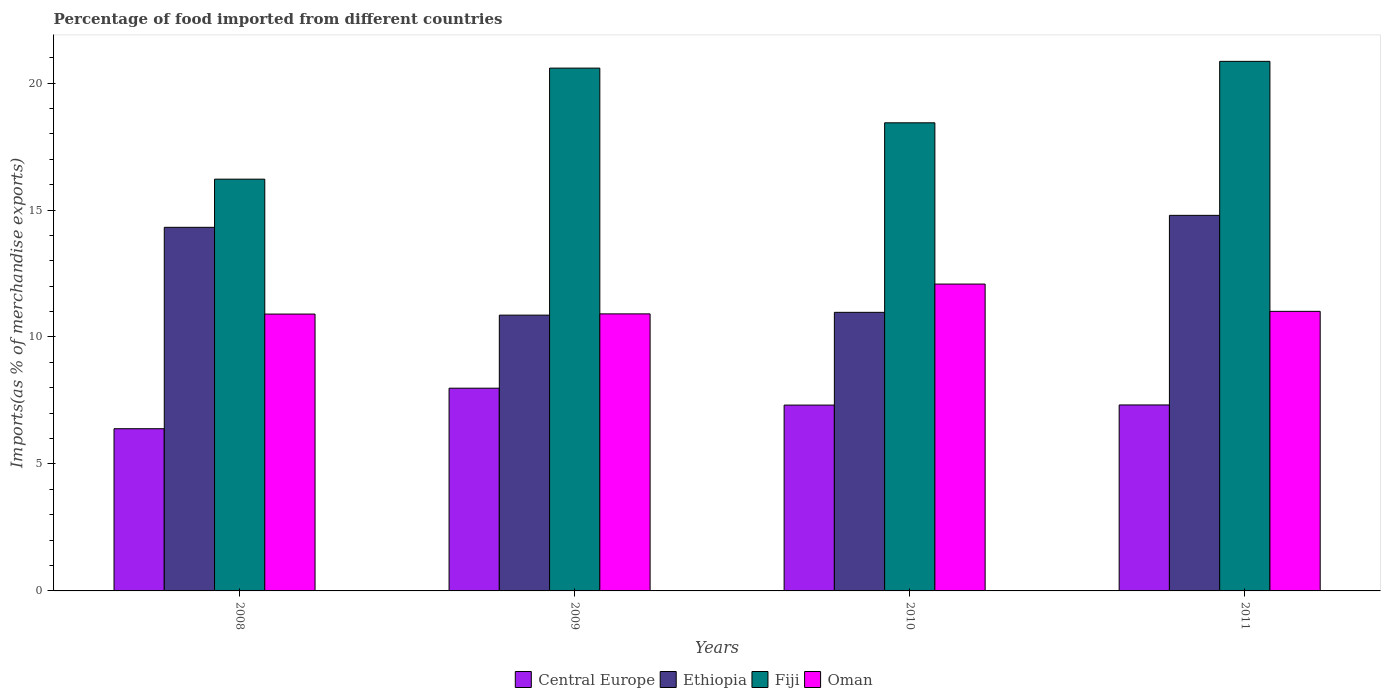How many different coloured bars are there?
Offer a very short reply. 4. How many groups of bars are there?
Offer a terse response. 4. Are the number of bars per tick equal to the number of legend labels?
Your answer should be very brief. Yes. How many bars are there on the 1st tick from the right?
Make the answer very short. 4. What is the label of the 3rd group of bars from the left?
Your answer should be very brief. 2010. What is the percentage of imports to different countries in Ethiopia in 2008?
Your answer should be compact. 14.32. Across all years, what is the maximum percentage of imports to different countries in Fiji?
Give a very brief answer. 20.85. Across all years, what is the minimum percentage of imports to different countries in Fiji?
Your answer should be compact. 16.22. In which year was the percentage of imports to different countries in Fiji maximum?
Provide a short and direct response. 2011. What is the total percentage of imports to different countries in Central Europe in the graph?
Give a very brief answer. 29.01. What is the difference between the percentage of imports to different countries in Central Europe in 2008 and that in 2010?
Give a very brief answer. -0.93. What is the difference between the percentage of imports to different countries in Central Europe in 2008 and the percentage of imports to different countries in Fiji in 2009?
Provide a succinct answer. -14.2. What is the average percentage of imports to different countries in Ethiopia per year?
Provide a succinct answer. 12.73. In the year 2010, what is the difference between the percentage of imports to different countries in Central Europe and percentage of imports to different countries in Fiji?
Offer a terse response. -11.12. What is the ratio of the percentage of imports to different countries in Ethiopia in 2008 to that in 2010?
Your answer should be compact. 1.31. Is the percentage of imports to different countries in Ethiopia in 2009 less than that in 2010?
Provide a succinct answer. Yes. Is the difference between the percentage of imports to different countries in Central Europe in 2008 and 2010 greater than the difference between the percentage of imports to different countries in Fiji in 2008 and 2010?
Your response must be concise. Yes. What is the difference between the highest and the second highest percentage of imports to different countries in Ethiopia?
Give a very brief answer. 0.47. What is the difference between the highest and the lowest percentage of imports to different countries in Ethiopia?
Offer a very short reply. 3.93. In how many years, is the percentage of imports to different countries in Ethiopia greater than the average percentage of imports to different countries in Ethiopia taken over all years?
Provide a succinct answer. 2. What does the 2nd bar from the left in 2008 represents?
Your answer should be compact. Ethiopia. What does the 4th bar from the right in 2010 represents?
Your answer should be very brief. Central Europe. Is it the case that in every year, the sum of the percentage of imports to different countries in Central Europe and percentage of imports to different countries in Oman is greater than the percentage of imports to different countries in Ethiopia?
Your answer should be compact. Yes. Where does the legend appear in the graph?
Your answer should be compact. Bottom center. How many legend labels are there?
Offer a terse response. 4. How are the legend labels stacked?
Make the answer very short. Horizontal. What is the title of the graph?
Keep it short and to the point. Percentage of food imported from different countries. What is the label or title of the Y-axis?
Offer a terse response. Imports(as % of merchandise exports). What is the Imports(as % of merchandise exports) in Central Europe in 2008?
Keep it short and to the point. 6.39. What is the Imports(as % of merchandise exports) in Ethiopia in 2008?
Your response must be concise. 14.32. What is the Imports(as % of merchandise exports) in Fiji in 2008?
Your answer should be very brief. 16.22. What is the Imports(as % of merchandise exports) in Oman in 2008?
Offer a terse response. 10.9. What is the Imports(as % of merchandise exports) in Central Europe in 2009?
Your answer should be very brief. 7.98. What is the Imports(as % of merchandise exports) of Ethiopia in 2009?
Keep it short and to the point. 10.86. What is the Imports(as % of merchandise exports) in Fiji in 2009?
Give a very brief answer. 20.59. What is the Imports(as % of merchandise exports) in Oman in 2009?
Keep it short and to the point. 10.91. What is the Imports(as % of merchandise exports) in Central Europe in 2010?
Provide a short and direct response. 7.32. What is the Imports(as % of merchandise exports) of Ethiopia in 2010?
Provide a succinct answer. 10.97. What is the Imports(as % of merchandise exports) in Fiji in 2010?
Provide a succinct answer. 18.43. What is the Imports(as % of merchandise exports) of Oman in 2010?
Provide a succinct answer. 12.08. What is the Imports(as % of merchandise exports) of Central Europe in 2011?
Your answer should be compact. 7.32. What is the Imports(as % of merchandise exports) of Ethiopia in 2011?
Your answer should be very brief. 14.79. What is the Imports(as % of merchandise exports) of Fiji in 2011?
Provide a succinct answer. 20.85. What is the Imports(as % of merchandise exports) of Oman in 2011?
Give a very brief answer. 11.01. Across all years, what is the maximum Imports(as % of merchandise exports) in Central Europe?
Give a very brief answer. 7.98. Across all years, what is the maximum Imports(as % of merchandise exports) in Ethiopia?
Give a very brief answer. 14.79. Across all years, what is the maximum Imports(as % of merchandise exports) of Fiji?
Provide a short and direct response. 20.85. Across all years, what is the maximum Imports(as % of merchandise exports) in Oman?
Make the answer very short. 12.08. Across all years, what is the minimum Imports(as % of merchandise exports) in Central Europe?
Your answer should be very brief. 6.39. Across all years, what is the minimum Imports(as % of merchandise exports) in Ethiopia?
Give a very brief answer. 10.86. Across all years, what is the minimum Imports(as % of merchandise exports) of Fiji?
Provide a short and direct response. 16.22. Across all years, what is the minimum Imports(as % of merchandise exports) of Oman?
Provide a short and direct response. 10.9. What is the total Imports(as % of merchandise exports) of Central Europe in the graph?
Your answer should be compact. 29.01. What is the total Imports(as % of merchandise exports) in Ethiopia in the graph?
Provide a short and direct response. 50.94. What is the total Imports(as % of merchandise exports) of Fiji in the graph?
Your answer should be very brief. 76.09. What is the total Imports(as % of merchandise exports) of Oman in the graph?
Ensure brevity in your answer.  44.91. What is the difference between the Imports(as % of merchandise exports) of Central Europe in 2008 and that in 2009?
Your answer should be compact. -1.6. What is the difference between the Imports(as % of merchandise exports) in Ethiopia in 2008 and that in 2009?
Your answer should be compact. 3.46. What is the difference between the Imports(as % of merchandise exports) in Fiji in 2008 and that in 2009?
Your answer should be very brief. -4.37. What is the difference between the Imports(as % of merchandise exports) in Oman in 2008 and that in 2009?
Offer a very short reply. -0.01. What is the difference between the Imports(as % of merchandise exports) of Central Europe in 2008 and that in 2010?
Offer a terse response. -0.93. What is the difference between the Imports(as % of merchandise exports) in Ethiopia in 2008 and that in 2010?
Ensure brevity in your answer.  3.35. What is the difference between the Imports(as % of merchandise exports) of Fiji in 2008 and that in 2010?
Give a very brief answer. -2.22. What is the difference between the Imports(as % of merchandise exports) of Oman in 2008 and that in 2010?
Your answer should be very brief. -1.18. What is the difference between the Imports(as % of merchandise exports) of Central Europe in 2008 and that in 2011?
Ensure brevity in your answer.  -0.94. What is the difference between the Imports(as % of merchandise exports) in Ethiopia in 2008 and that in 2011?
Keep it short and to the point. -0.47. What is the difference between the Imports(as % of merchandise exports) of Fiji in 2008 and that in 2011?
Provide a short and direct response. -4.64. What is the difference between the Imports(as % of merchandise exports) of Oman in 2008 and that in 2011?
Your answer should be compact. -0.11. What is the difference between the Imports(as % of merchandise exports) of Central Europe in 2009 and that in 2010?
Your answer should be compact. 0.67. What is the difference between the Imports(as % of merchandise exports) in Ethiopia in 2009 and that in 2010?
Offer a terse response. -0.11. What is the difference between the Imports(as % of merchandise exports) in Fiji in 2009 and that in 2010?
Ensure brevity in your answer.  2.15. What is the difference between the Imports(as % of merchandise exports) of Oman in 2009 and that in 2010?
Your answer should be very brief. -1.17. What is the difference between the Imports(as % of merchandise exports) of Central Europe in 2009 and that in 2011?
Offer a very short reply. 0.66. What is the difference between the Imports(as % of merchandise exports) of Ethiopia in 2009 and that in 2011?
Your answer should be compact. -3.93. What is the difference between the Imports(as % of merchandise exports) in Fiji in 2009 and that in 2011?
Provide a succinct answer. -0.27. What is the difference between the Imports(as % of merchandise exports) in Oman in 2009 and that in 2011?
Your answer should be very brief. -0.1. What is the difference between the Imports(as % of merchandise exports) in Central Europe in 2010 and that in 2011?
Your response must be concise. -0.01. What is the difference between the Imports(as % of merchandise exports) in Ethiopia in 2010 and that in 2011?
Keep it short and to the point. -3.82. What is the difference between the Imports(as % of merchandise exports) of Fiji in 2010 and that in 2011?
Your response must be concise. -2.42. What is the difference between the Imports(as % of merchandise exports) of Oman in 2010 and that in 2011?
Provide a succinct answer. 1.07. What is the difference between the Imports(as % of merchandise exports) of Central Europe in 2008 and the Imports(as % of merchandise exports) of Ethiopia in 2009?
Make the answer very short. -4.47. What is the difference between the Imports(as % of merchandise exports) in Central Europe in 2008 and the Imports(as % of merchandise exports) in Fiji in 2009?
Your answer should be very brief. -14.2. What is the difference between the Imports(as % of merchandise exports) of Central Europe in 2008 and the Imports(as % of merchandise exports) of Oman in 2009?
Offer a terse response. -4.52. What is the difference between the Imports(as % of merchandise exports) in Ethiopia in 2008 and the Imports(as % of merchandise exports) in Fiji in 2009?
Offer a terse response. -6.27. What is the difference between the Imports(as % of merchandise exports) of Ethiopia in 2008 and the Imports(as % of merchandise exports) of Oman in 2009?
Your response must be concise. 3.41. What is the difference between the Imports(as % of merchandise exports) of Fiji in 2008 and the Imports(as % of merchandise exports) of Oman in 2009?
Give a very brief answer. 5.31. What is the difference between the Imports(as % of merchandise exports) in Central Europe in 2008 and the Imports(as % of merchandise exports) in Ethiopia in 2010?
Provide a succinct answer. -4.58. What is the difference between the Imports(as % of merchandise exports) of Central Europe in 2008 and the Imports(as % of merchandise exports) of Fiji in 2010?
Your answer should be very brief. -12.05. What is the difference between the Imports(as % of merchandise exports) in Central Europe in 2008 and the Imports(as % of merchandise exports) in Oman in 2010?
Ensure brevity in your answer.  -5.7. What is the difference between the Imports(as % of merchandise exports) of Ethiopia in 2008 and the Imports(as % of merchandise exports) of Fiji in 2010?
Give a very brief answer. -4.12. What is the difference between the Imports(as % of merchandise exports) of Ethiopia in 2008 and the Imports(as % of merchandise exports) of Oman in 2010?
Ensure brevity in your answer.  2.23. What is the difference between the Imports(as % of merchandise exports) in Fiji in 2008 and the Imports(as % of merchandise exports) in Oman in 2010?
Keep it short and to the point. 4.13. What is the difference between the Imports(as % of merchandise exports) of Central Europe in 2008 and the Imports(as % of merchandise exports) of Ethiopia in 2011?
Your answer should be compact. -8.4. What is the difference between the Imports(as % of merchandise exports) in Central Europe in 2008 and the Imports(as % of merchandise exports) in Fiji in 2011?
Provide a short and direct response. -14.47. What is the difference between the Imports(as % of merchandise exports) of Central Europe in 2008 and the Imports(as % of merchandise exports) of Oman in 2011?
Provide a succinct answer. -4.62. What is the difference between the Imports(as % of merchandise exports) of Ethiopia in 2008 and the Imports(as % of merchandise exports) of Fiji in 2011?
Keep it short and to the point. -6.54. What is the difference between the Imports(as % of merchandise exports) of Ethiopia in 2008 and the Imports(as % of merchandise exports) of Oman in 2011?
Your response must be concise. 3.31. What is the difference between the Imports(as % of merchandise exports) of Fiji in 2008 and the Imports(as % of merchandise exports) of Oman in 2011?
Make the answer very short. 5.21. What is the difference between the Imports(as % of merchandise exports) in Central Europe in 2009 and the Imports(as % of merchandise exports) in Ethiopia in 2010?
Offer a very short reply. -2.99. What is the difference between the Imports(as % of merchandise exports) in Central Europe in 2009 and the Imports(as % of merchandise exports) in Fiji in 2010?
Offer a terse response. -10.45. What is the difference between the Imports(as % of merchandise exports) of Central Europe in 2009 and the Imports(as % of merchandise exports) of Oman in 2010?
Give a very brief answer. -4.1. What is the difference between the Imports(as % of merchandise exports) in Ethiopia in 2009 and the Imports(as % of merchandise exports) in Fiji in 2010?
Offer a very short reply. -7.57. What is the difference between the Imports(as % of merchandise exports) in Ethiopia in 2009 and the Imports(as % of merchandise exports) in Oman in 2010?
Your response must be concise. -1.22. What is the difference between the Imports(as % of merchandise exports) in Fiji in 2009 and the Imports(as % of merchandise exports) in Oman in 2010?
Provide a short and direct response. 8.5. What is the difference between the Imports(as % of merchandise exports) of Central Europe in 2009 and the Imports(as % of merchandise exports) of Ethiopia in 2011?
Make the answer very short. -6.81. What is the difference between the Imports(as % of merchandise exports) in Central Europe in 2009 and the Imports(as % of merchandise exports) in Fiji in 2011?
Your answer should be compact. -12.87. What is the difference between the Imports(as % of merchandise exports) in Central Europe in 2009 and the Imports(as % of merchandise exports) in Oman in 2011?
Offer a very short reply. -3.03. What is the difference between the Imports(as % of merchandise exports) of Ethiopia in 2009 and the Imports(as % of merchandise exports) of Fiji in 2011?
Provide a short and direct response. -9.99. What is the difference between the Imports(as % of merchandise exports) in Ethiopia in 2009 and the Imports(as % of merchandise exports) in Oman in 2011?
Offer a very short reply. -0.15. What is the difference between the Imports(as % of merchandise exports) in Fiji in 2009 and the Imports(as % of merchandise exports) in Oman in 2011?
Offer a terse response. 9.58. What is the difference between the Imports(as % of merchandise exports) in Central Europe in 2010 and the Imports(as % of merchandise exports) in Ethiopia in 2011?
Offer a terse response. -7.47. What is the difference between the Imports(as % of merchandise exports) of Central Europe in 2010 and the Imports(as % of merchandise exports) of Fiji in 2011?
Offer a very short reply. -13.54. What is the difference between the Imports(as % of merchandise exports) in Central Europe in 2010 and the Imports(as % of merchandise exports) in Oman in 2011?
Offer a terse response. -3.69. What is the difference between the Imports(as % of merchandise exports) of Ethiopia in 2010 and the Imports(as % of merchandise exports) of Fiji in 2011?
Your answer should be compact. -9.88. What is the difference between the Imports(as % of merchandise exports) of Ethiopia in 2010 and the Imports(as % of merchandise exports) of Oman in 2011?
Your answer should be very brief. -0.04. What is the difference between the Imports(as % of merchandise exports) in Fiji in 2010 and the Imports(as % of merchandise exports) in Oman in 2011?
Offer a terse response. 7.43. What is the average Imports(as % of merchandise exports) of Central Europe per year?
Ensure brevity in your answer.  7.25. What is the average Imports(as % of merchandise exports) of Ethiopia per year?
Offer a terse response. 12.73. What is the average Imports(as % of merchandise exports) of Fiji per year?
Ensure brevity in your answer.  19.02. What is the average Imports(as % of merchandise exports) in Oman per year?
Your answer should be compact. 11.23. In the year 2008, what is the difference between the Imports(as % of merchandise exports) in Central Europe and Imports(as % of merchandise exports) in Ethiopia?
Offer a very short reply. -7.93. In the year 2008, what is the difference between the Imports(as % of merchandise exports) of Central Europe and Imports(as % of merchandise exports) of Fiji?
Offer a terse response. -9.83. In the year 2008, what is the difference between the Imports(as % of merchandise exports) of Central Europe and Imports(as % of merchandise exports) of Oman?
Give a very brief answer. -4.51. In the year 2008, what is the difference between the Imports(as % of merchandise exports) in Ethiopia and Imports(as % of merchandise exports) in Fiji?
Offer a very short reply. -1.9. In the year 2008, what is the difference between the Imports(as % of merchandise exports) of Ethiopia and Imports(as % of merchandise exports) of Oman?
Make the answer very short. 3.42. In the year 2008, what is the difference between the Imports(as % of merchandise exports) of Fiji and Imports(as % of merchandise exports) of Oman?
Give a very brief answer. 5.31. In the year 2009, what is the difference between the Imports(as % of merchandise exports) in Central Europe and Imports(as % of merchandise exports) in Ethiopia?
Ensure brevity in your answer.  -2.88. In the year 2009, what is the difference between the Imports(as % of merchandise exports) in Central Europe and Imports(as % of merchandise exports) in Fiji?
Your answer should be very brief. -12.6. In the year 2009, what is the difference between the Imports(as % of merchandise exports) of Central Europe and Imports(as % of merchandise exports) of Oman?
Offer a terse response. -2.93. In the year 2009, what is the difference between the Imports(as % of merchandise exports) in Ethiopia and Imports(as % of merchandise exports) in Fiji?
Your answer should be compact. -9.73. In the year 2009, what is the difference between the Imports(as % of merchandise exports) in Ethiopia and Imports(as % of merchandise exports) in Oman?
Give a very brief answer. -0.05. In the year 2009, what is the difference between the Imports(as % of merchandise exports) in Fiji and Imports(as % of merchandise exports) in Oman?
Your answer should be very brief. 9.68. In the year 2010, what is the difference between the Imports(as % of merchandise exports) in Central Europe and Imports(as % of merchandise exports) in Ethiopia?
Keep it short and to the point. -3.65. In the year 2010, what is the difference between the Imports(as % of merchandise exports) of Central Europe and Imports(as % of merchandise exports) of Fiji?
Give a very brief answer. -11.12. In the year 2010, what is the difference between the Imports(as % of merchandise exports) in Central Europe and Imports(as % of merchandise exports) in Oman?
Ensure brevity in your answer.  -4.77. In the year 2010, what is the difference between the Imports(as % of merchandise exports) of Ethiopia and Imports(as % of merchandise exports) of Fiji?
Offer a very short reply. -7.46. In the year 2010, what is the difference between the Imports(as % of merchandise exports) of Ethiopia and Imports(as % of merchandise exports) of Oman?
Ensure brevity in your answer.  -1.11. In the year 2010, what is the difference between the Imports(as % of merchandise exports) in Fiji and Imports(as % of merchandise exports) in Oman?
Keep it short and to the point. 6.35. In the year 2011, what is the difference between the Imports(as % of merchandise exports) in Central Europe and Imports(as % of merchandise exports) in Ethiopia?
Ensure brevity in your answer.  -7.47. In the year 2011, what is the difference between the Imports(as % of merchandise exports) in Central Europe and Imports(as % of merchandise exports) in Fiji?
Ensure brevity in your answer.  -13.53. In the year 2011, what is the difference between the Imports(as % of merchandise exports) of Central Europe and Imports(as % of merchandise exports) of Oman?
Make the answer very short. -3.69. In the year 2011, what is the difference between the Imports(as % of merchandise exports) of Ethiopia and Imports(as % of merchandise exports) of Fiji?
Offer a very short reply. -6.06. In the year 2011, what is the difference between the Imports(as % of merchandise exports) in Ethiopia and Imports(as % of merchandise exports) in Oman?
Keep it short and to the point. 3.78. In the year 2011, what is the difference between the Imports(as % of merchandise exports) in Fiji and Imports(as % of merchandise exports) in Oman?
Offer a very short reply. 9.84. What is the ratio of the Imports(as % of merchandise exports) in Central Europe in 2008 to that in 2009?
Provide a short and direct response. 0.8. What is the ratio of the Imports(as % of merchandise exports) of Ethiopia in 2008 to that in 2009?
Your answer should be compact. 1.32. What is the ratio of the Imports(as % of merchandise exports) of Fiji in 2008 to that in 2009?
Provide a succinct answer. 0.79. What is the ratio of the Imports(as % of merchandise exports) of Oman in 2008 to that in 2009?
Your answer should be very brief. 1. What is the ratio of the Imports(as % of merchandise exports) in Central Europe in 2008 to that in 2010?
Ensure brevity in your answer.  0.87. What is the ratio of the Imports(as % of merchandise exports) of Ethiopia in 2008 to that in 2010?
Provide a short and direct response. 1.31. What is the ratio of the Imports(as % of merchandise exports) of Fiji in 2008 to that in 2010?
Ensure brevity in your answer.  0.88. What is the ratio of the Imports(as % of merchandise exports) in Oman in 2008 to that in 2010?
Your response must be concise. 0.9. What is the ratio of the Imports(as % of merchandise exports) of Central Europe in 2008 to that in 2011?
Offer a terse response. 0.87. What is the ratio of the Imports(as % of merchandise exports) of Ethiopia in 2008 to that in 2011?
Give a very brief answer. 0.97. What is the ratio of the Imports(as % of merchandise exports) of Fiji in 2008 to that in 2011?
Your answer should be very brief. 0.78. What is the ratio of the Imports(as % of merchandise exports) of Oman in 2008 to that in 2011?
Offer a very short reply. 0.99. What is the ratio of the Imports(as % of merchandise exports) of Ethiopia in 2009 to that in 2010?
Keep it short and to the point. 0.99. What is the ratio of the Imports(as % of merchandise exports) of Fiji in 2009 to that in 2010?
Offer a very short reply. 1.12. What is the ratio of the Imports(as % of merchandise exports) in Oman in 2009 to that in 2010?
Your answer should be very brief. 0.9. What is the ratio of the Imports(as % of merchandise exports) of Central Europe in 2009 to that in 2011?
Ensure brevity in your answer.  1.09. What is the ratio of the Imports(as % of merchandise exports) of Ethiopia in 2009 to that in 2011?
Make the answer very short. 0.73. What is the ratio of the Imports(as % of merchandise exports) of Fiji in 2009 to that in 2011?
Offer a terse response. 0.99. What is the ratio of the Imports(as % of merchandise exports) of Oman in 2009 to that in 2011?
Your response must be concise. 0.99. What is the ratio of the Imports(as % of merchandise exports) of Ethiopia in 2010 to that in 2011?
Keep it short and to the point. 0.74. What is the ratio of the Imports(as % of merchandise exports) of Fiji in 2010 to that in 2011?
Ensure brevity in your answer.  0.88. What is the ratio of the Imports(as % of merchandise exports) in Oman in 2010 to that in 2011?
Offer a terse response. 1.1. What is the difference between the highest and the second highest Imports(as % of merchandise exports) of Central Europe?
Make the answer very short. 0.66. What is the difference between the highest and the second highest Imports(as % of merchandise exports) in Ethiopia?
Offer a terse response. 0.47. What is the difference between the highest and the second highest Imports(as % of merchandise exports) in Fiji?
Offer a terse response. 0.27. What is the difference between the highest and the second highest Imports(as % of merchandise exports) of Oman?
Your response must be concise. 1.07. What is the difference between the highest and the lowest Imports(as % of merchandise exports) of Central Europe?
Keep it short and to the point. 1.6. What is the difference between the highest and the lowest Imports(as % of merchandise exports) in Ethiopia?
Give a very brief answer. 3.93. What is the difference between the highest and the lowest Imports(as % of merchandise exports) of Fiji?
Keep it short and to the point. 4.64. What is the difference between the highest and the lowest Imports(as % of merchandise exports) of Oman?
Your answer should be very brief. 1.18. 